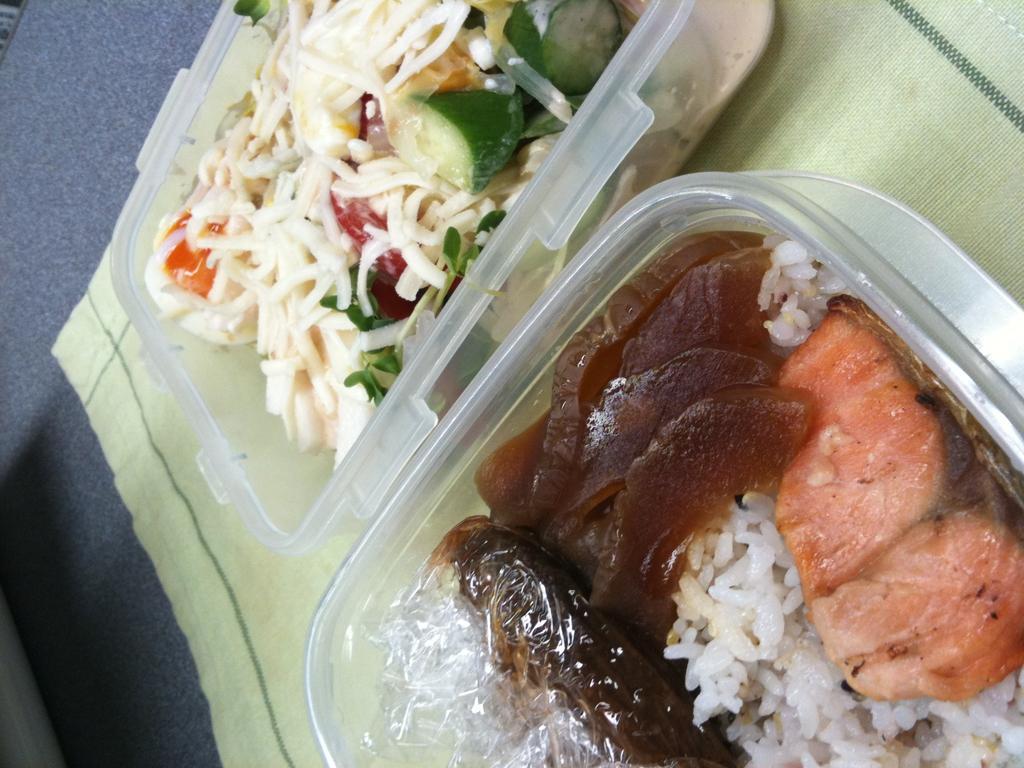Please provide a concise description of this image. In this image I can see two boxes kept on the floor in boxes I can see food. 